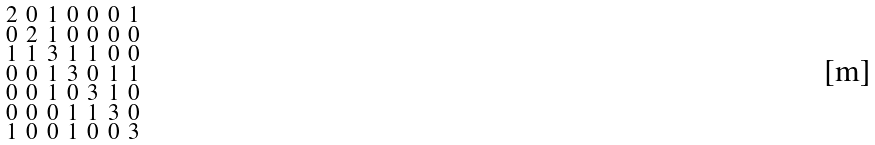<formula> <loc_0><loc_0><loc_500><loc_500>\begin{smallmatrix} 2 & 0 & 1 & 0 & 0 & 0 & 1 \\ 0 & 2 & 1 & 0 & 0 & 0 & 0 \\ 1 & 1 & 3 & 1 & 1 & 0 & 0 \\ 0 & 0 & 1 & 3 & 0 & 1 & 1 \\ 0 & 0 & 1 & 0 & 3 & 1 & 0 \\ 0 & 0 & 0 & 1 & 1 & 3 & 0 \\ 1 & 0 & 0 & 1 & 0 & 0 & 3 \end{smallmatrix}</formula> 